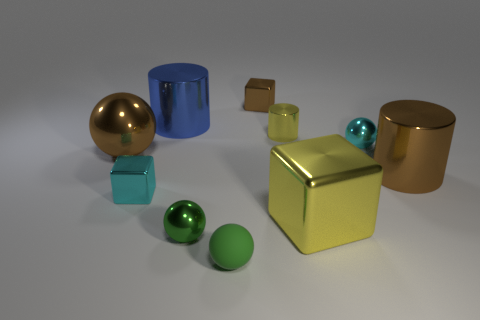Subtract all brown shiny balls. How many balls are left? 3 Subtract all yellow cubes. How many green balls are left? 2 Subtract all brown spheres. How many spheres are left? 3 Subtract all cyan cylinders. Subtract all cyan balls. How many cylinders are left? 3 Subtract 0 red balls. How many objects are left? 10 Subtract all cylinders. How many objects are left? 7 Subtract all large blue balls. Subtract all brown objects. How many objects are left? 7 Add 7 tiny green rubber objects. How many tiny green rubber objects are left? 8 Add 1 big cyan objects. How many big cyan objects exist? 1 